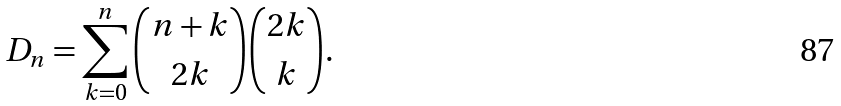Convert formula to latex. <formula><loc_0><loc_0><loc_500><loc_500>D _ { n } = \sum _ { k = 0 } ^ { n } { n + k \choose 2 k } { 2 k \choose k } .</formula> 